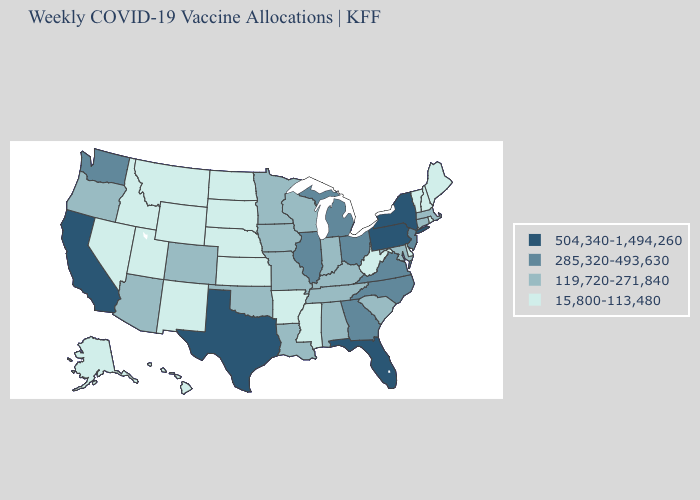Does Nevada have the highest value in the West?
Write a very short answer. No. Name the states that have a value in the range 119,720-271,840?
Keep it brief. Alabama, Arizona, Colorado, Connecticut, Indiana, Iowa, Kentucky, Louisiana, Maryland, Massachusetts, Minnesota, Missouri, Oklahoma, Oregon, South Carolina, Tennessee, Wisconsin. Name the states that have a value in the range 504,340-1,494,260?
Short answer required. California, Florida, New York, Pennsylvania, Texas. What is the value of Wyoming?
Quick response, please. 15,800-113,480. What is the value of Wisconsin?
Write a very short answer. 119,720-271,840. Does Utah have the highest value in the West?
Concise answer only. No. What is the highest value in the USA?
Keep it brief. 504,340-1,494,260. Which states have the lowest value in the MidWest?
Give a very brief answer. Kansas, Nebraska, North Dakota, South Dakota. What is the lowest value in the South?
Keep it brief. 15,800-113,480. Among the states that border North Dakota , does Minnesota have the lowest value?
Quick response, please. No. Does Maryland have the lowest value in the USA?
Keep it brief. No. Among the states that border Colorado , does Arizona have the highest value?
Give a very brief answer. Yes. Among the states that border Idaho , which have the highest value?
Short answer required. Washington. Does Maryland have a lower value than Maine?
Concise answer only. No. Does West Virginia have the lowest value in the USA?
Concise answer only. Yes. 